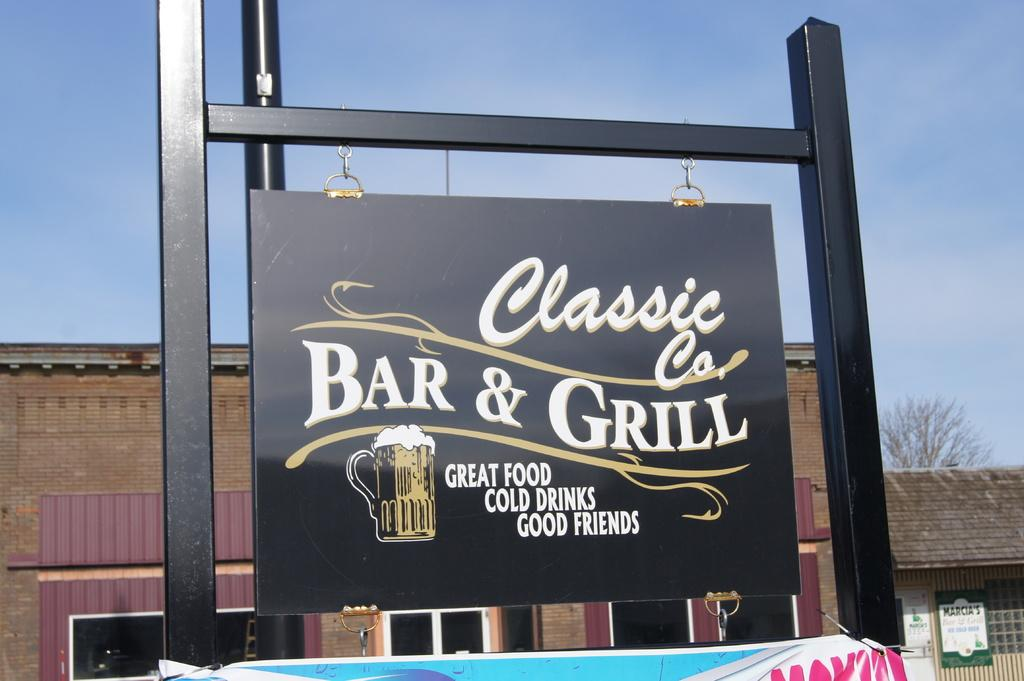<image>
Relay a brief, clear account of the picture shown. Classic Co. Bar and Grill sign that says Great Food, Cold Drinks, and Good Friends. 